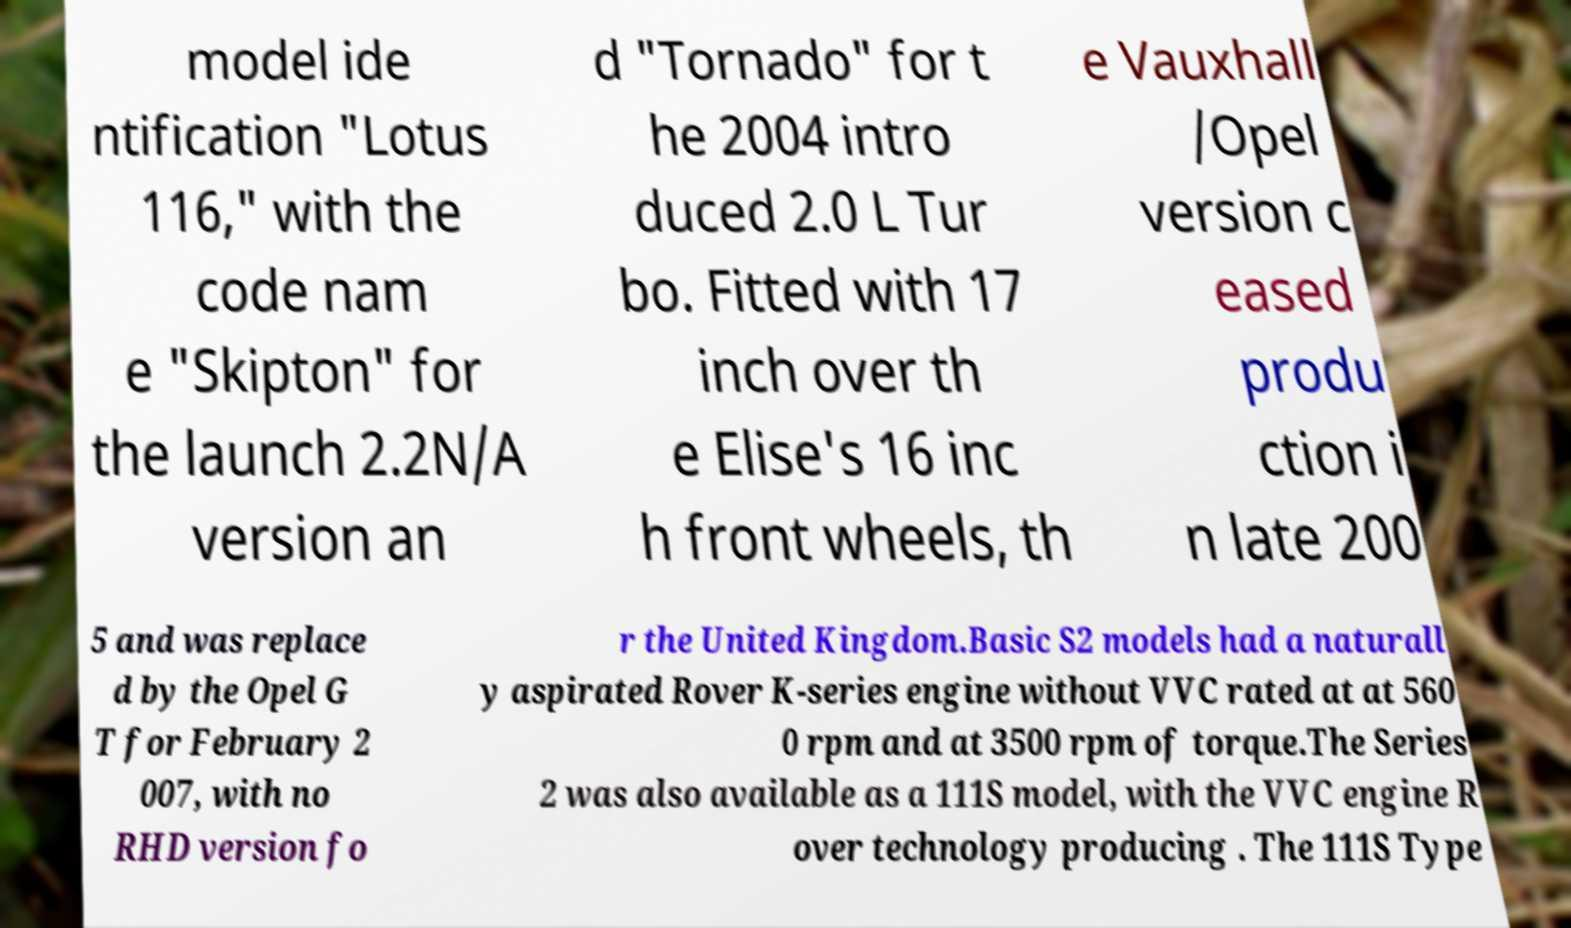Please read and relay the text visible in this image. What does it say? model ide ntification "Lotus 116," with the code nam e "Skipton" for the launch 2.2N/A version an d "Tornado" for t he 2004 intro duced 2.0 L Tur bo. Fitted with 17 inch over th e Elise's 16 inc h front wheels, th e Vauxhall /Opel version c eased produ ction i n late 200 5 and was replace d by the Opel G T for February 2 007, with no RHD version fo r the United Kingdom.Basic S2 models had a naturall y aspirated Rover K-series engine without VVC rated at at 560 0 rpm and at 3500 rpm of torque.The Series 2 was also available as a 111S model, with the VVC engine R over technology producing . The 111S Type 